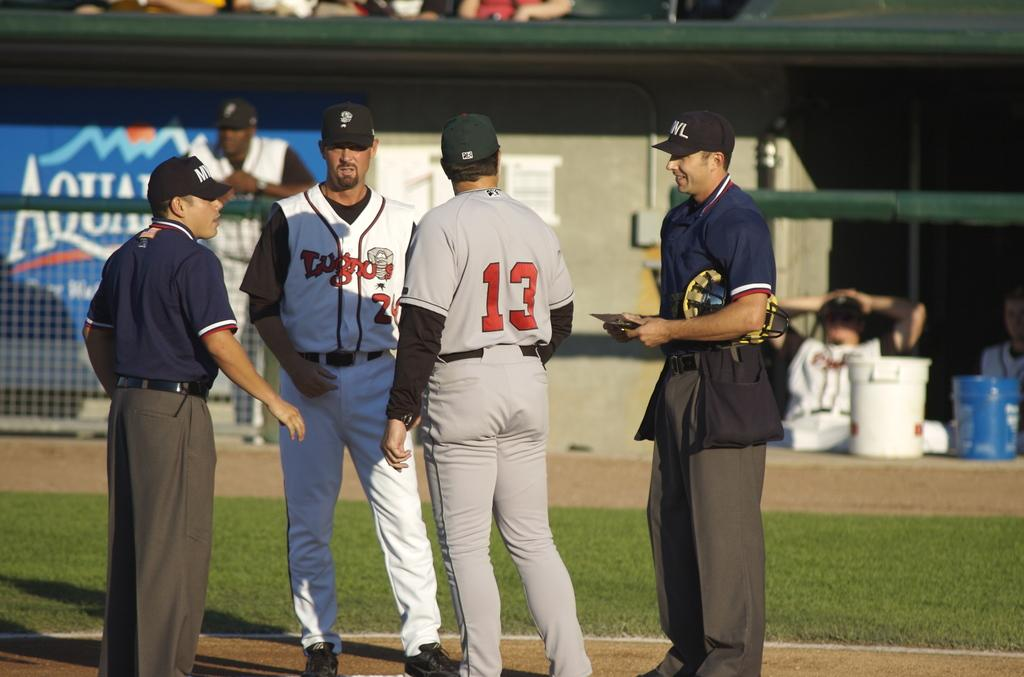<image>
Create a compact narrative representing the image presented. a person wearing the number 13 on a field 